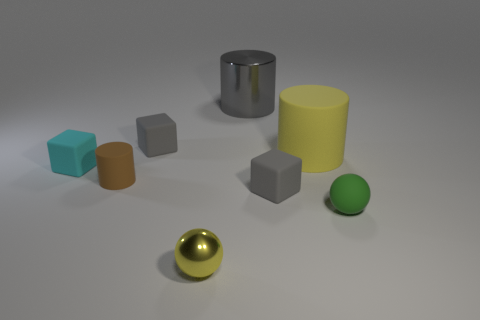Which object appears to be the largest and what might its size be relative to the others? The largest object in the image is the gray cylinder in the center. It towers over the other shapes, appearing to be roughly twice the height of the yellow cylinder and significantly wider than any of the blocks or the spheres.  And what about the smallest object? The smallest object is the green sphere to the right of the image. It appears to be about a quarter of the size of the brown cylinder next to it and notably smaller than any other object in the scene. 